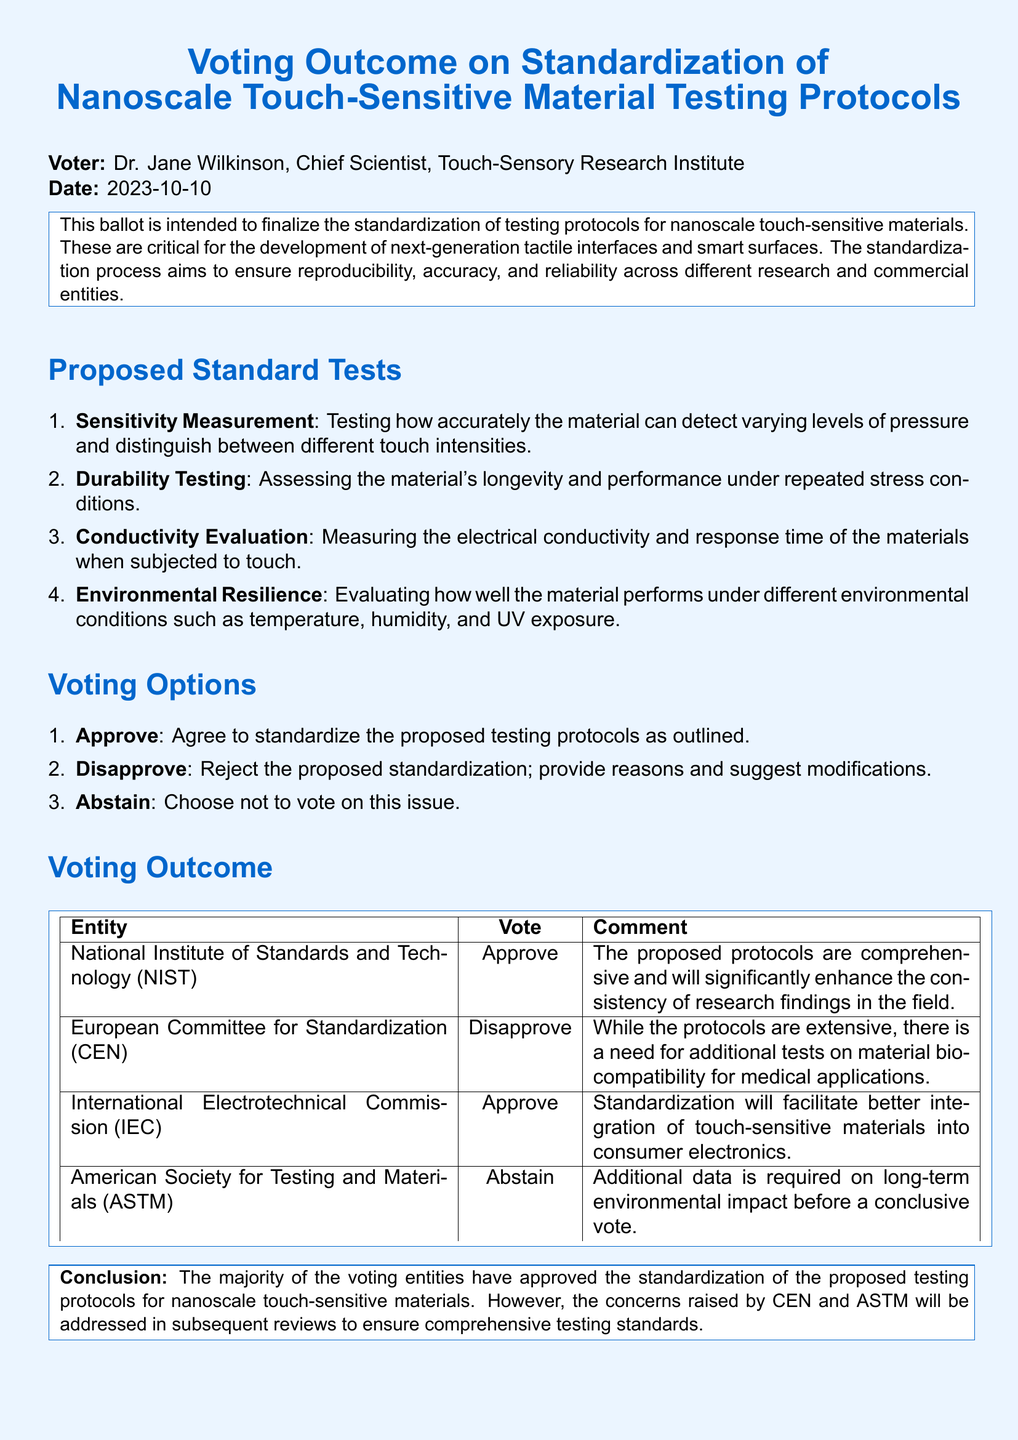What is the date of the ballot? The date is explicitly mentioned in the document under the voter section.
Answer: 2023-10-10 Who is the voter? The voter's name and title are provided in the document.
Answer: Dr. Jane Wilkinson What organization approved the proposed protocols? Several organizations are listed with their votes; one approved entity is required.
Answer: National Institute of Standards and Technology (NIST) What is one concern raised by CEN? CEN's disapproval includes a specific concern that is directly quoted.
Answer: Need for additional tests on material biocompatibility for medical applications How many proposed standard tests are there? The number of proposed tests is explicitly counted in the list provided.
Answer: Four What is the voting option for those who do not wish to vote? The document outlines voting options that include a specific choice.
Answer: Abstain What is the conclusion about the voting outcome? The conclusion provides a summary of the voting results and addresses specific concerns.
Answer: Majority approved Which organization's vote was marked as abstain? The document explicitly lists the organization that did not vote.
Answer: American Society for Testing and Materials (ASTM) 